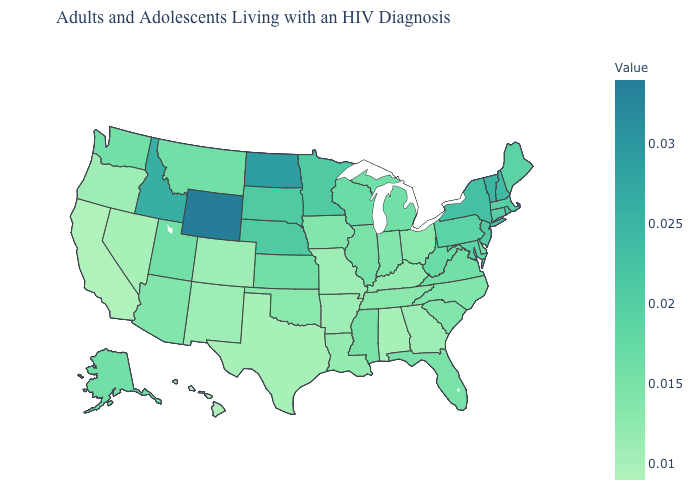Among the states that border Washington , which have the highest value?
Quick response, please. Idaho. Among the states that border Alabama , which have the highest value?
Give a very brief answer. Florida, Mississippi. Does the map have missing data?
Short answer required. No. 